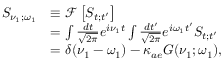Convert formula to latex. <formula><loc_0><loc_0><loc_500><loc_500>\begin{array} { r l } { S _ { \nu _ { 1 } ; \omega _ { 1 } } } & { \equiv \ m a t h s c r { F } \left [ S _ { t ; t ^ { \prime } } \right ] } \\ & { = \int \frac { d t } { \sqrt { 2 \pi } } e ^ { i \nu _ { 1 } t } \int \frac { d t ^ { \prime } } { \sqrt { 2 \pi } } e ^ { i \omega _ { 1 } t ^ { \prime } } S _ { t ; t ^ { \prime } } } \\ & { = \delta ( \nu _ { 1 } - \omega _ { 1 } ) - \kappa _ { a e } G ( \nu _ { 1 } ; \omega _ { 1 } ) , } \end{array}</formula> 